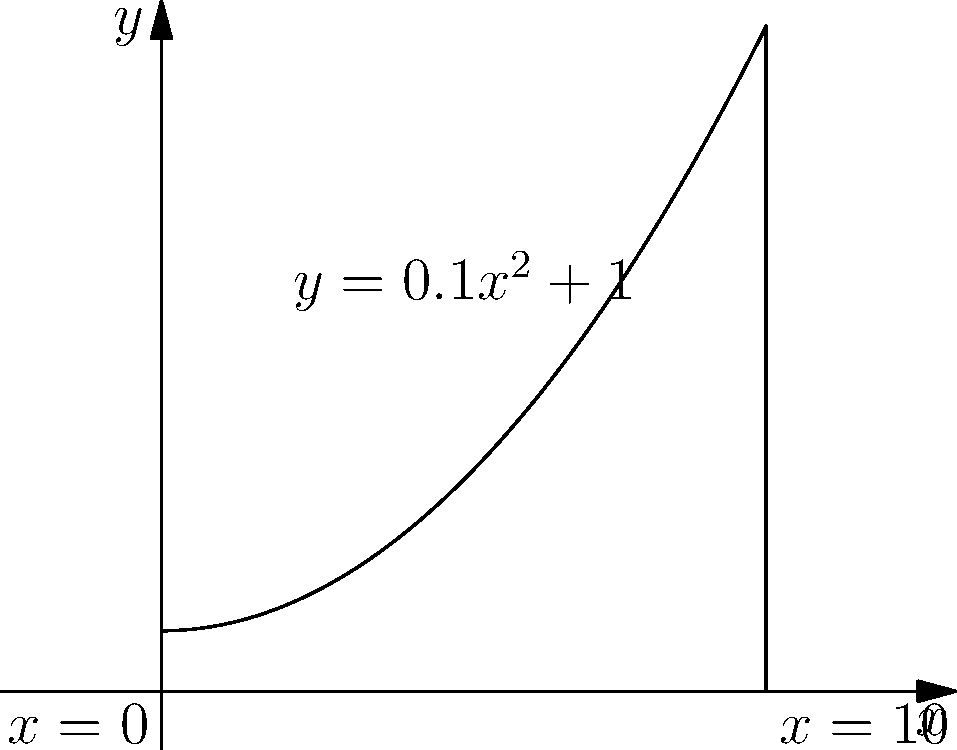As a dedicated Sandbanks resident, you're involved in a beach replenishment project. A curved section of the beach needs sand, and its profile is represented by the function $y = 0.1x^2 + 1$, where $x$ and $y$ are measured in meters. If this section extends from $x = 0$ to $x = 10$, what volume of sand (in cubic meters) is needed to fill this area when rotated around the x-axis? To solve this problem, we need to use the volume formula for solids of revolution:

1) The volume is given by $V = \pi \int_a^b [f(x)]^2 dx$, where $f(x) = 0.1x^2 + 1$

2) Substituting the function and limits:
   $V = \pi \int_0^{10} (0.1x^2 + 1)^2 dx$

3) Expand the integrand:
   $(0.1x^2 + 1)^2 = 0.01x^4 + 0.2x^2 + 1$

4) Now our integral is:
   $V = \pi \int_0^{10} (0.01x^4 + 0.2x^2 + 1) dx$

5) Integrate term by term:
   $V = \pi [\frac{0.01x^5}{5} + \frac{0.2x^3}{3} + x]_0^{10}$

6) Evaluate the integral:
   $V = \pi [(\frac{0.01 \cdot 10^5}{5} + \frac{0.2 \cdot 10^3}{3} + 10) - (0 + 0 + 0)]$
   $V = \pi [200 + 666.67 + 10]$
   $V = \pi [876.67]$

7) Calculate the final result:
   $V \approx 2754.82$ cubic meters

Therefore, approximately 2754.82 cubic meters of sand are needed to fill this curved section of the beach.
Answer: $2754.82$ cubic meters 